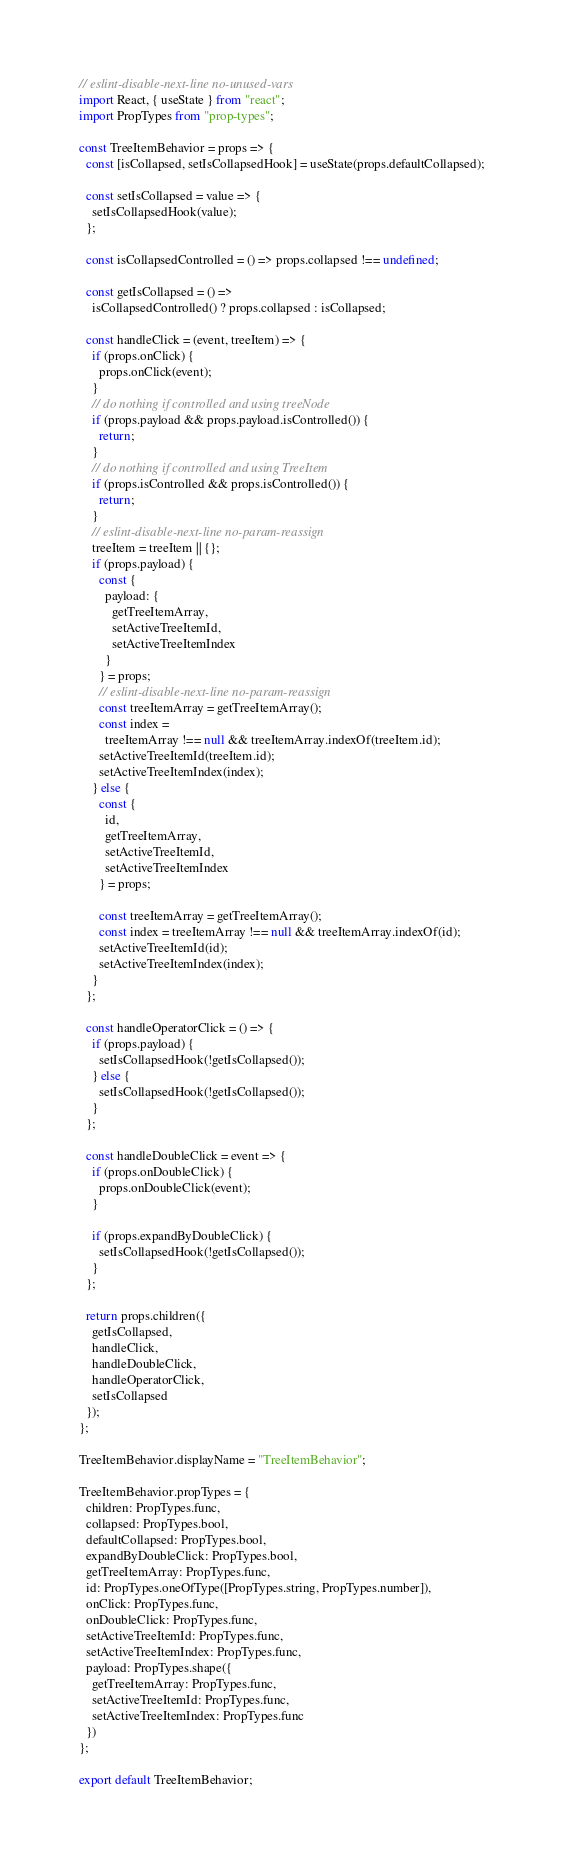Convert code to text. <code><loc_0><loc_0><loc_500><loc_500><_JavaScript_>// eslint-disable-next-line no-unused-vars
import React, { useState } from "react";
import PropTypes from "prop-types";

const TreeItemBehavior = props => {
  const [isCollapsed, setIsCollapsedHook] = useState(props.defaultCollapsed);

  const setIsCollapsed = value => {
    setIsCollapsedHook(value);
  };

  const isCollapsedControlled = () => props.collapsed !== undefined;

  const getIsCollapsed = () =>
    isCollapsedControlled() ? props.collapsed : isCollapsed;

  const handleClick = (event, treeItem) => {
    if (props.onClick) {
      props.onClick(event);
    }
    // do nothing if controlled and using treeNode
    if (props.payload && props.payload.isControlled()) {
      return;
    }
    // do nothing if controlled and using TreeItem
    if (props.isControlled && props.isControlled()) {
      return;
    }
    // eslint-disable-next-line no-param-reassign
    treeItem = treeItem || {};
    if (props.payload) {
      const {
        payload: {
          getTreeItemArray,
          setActiveTreeItemId,
          setActiveTreeItemIndex
        }
      } = props;
      // eslint-disable-next-line no-param-reassign
      const treeItemArray = getTreeItemArray();
      const index =
        treeItemArray !== null && treeItemArray.indexOf(treeItem.id);
      setActiveTreeItemId(treeItem.id);
      setActiveTreeItemIndex(index);
    } else {
      const {
        id,
        getTreeItemArray,
        setActiveTreeItemId,
        setActiveTreeItemIndex
      } = props;

      const treeItemArray = getTreeItemArray();
      const index = treeItemArray !== null && treeItemArray.indexOf(id);
      setActiveTreeItemId(id);
      setActiveTreeItemIndex(index);
    }
  };

  const handleOperatorClick = () => {
    if (props.payload) {
      setIsCollapsedHook(!getIsCollapsed());
    } else {
      setIsCollapsedHook(!getIsCollapsed());
    }
  };

  const handleDoubleClick = event => {
    if (props.onDoubleClick) {
      props.onDoubleClick(event);
    }

    if (props.expandByDoubleClick) {
      setIsCollapsedHook(!getIsCollapsed());
    }
  };

  return props.children({
    getIsCollapsed,
    handleClick,
    handleDoubleClick,
    handleOperatorClick,
    setIsCollapsed
  });
};

TreeItemBehavior.displayName = "TreeItemBehavior";

TreeItemBehavior.propTypes = {
  children: PropTypes.func,
  collapsed: PropTypes.bool,
  defaultCollapsed: PropTypes.bool,
  expandByDoubleClick: PropTypes.bool,
  getTreeItemArray: PropTypes.func,
  id: PropTypes.oneOfType([PropTypes.string, PropTypes.number]),
  onClick: PropTypes.func,
  onDoubleClick: PropTypes.func,
  setActiveTreeItemId: PropTypes.func,
  setActiveTreeItemIndex: PropTypes.func,
  payload: PropTypes.shape({
    getTreeItemArray: PropTypes.func,
    setActiveTreeItemId: PropTypes.func,
    setActiveTreeItemIndex: PropTypes.func
  })
};

export default TreeItemBehavior;
</code> 